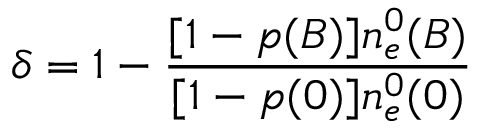<formula> <loc_0><loc_0><loc_500><loc_500>\delta = 1 - \frac { [ 1 - p ( B ) ] n _ { e } ^ { 0 } ( B ) } { [ 1 - p ( 0 ) ] n _ { e } ^ { 0 } ( 0 ) }</formula> 